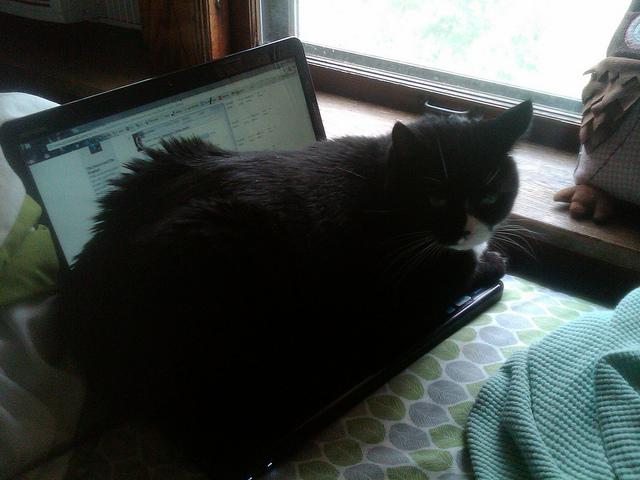Is the cat resting on a heater pad?
Be succinct. No. Is any human currently typing on this laptop?
Quick response, please. No. Is the computer turned on?
Keep it brief. Yes. What species of cats is looking outside the window?
Quick response, please. None. 